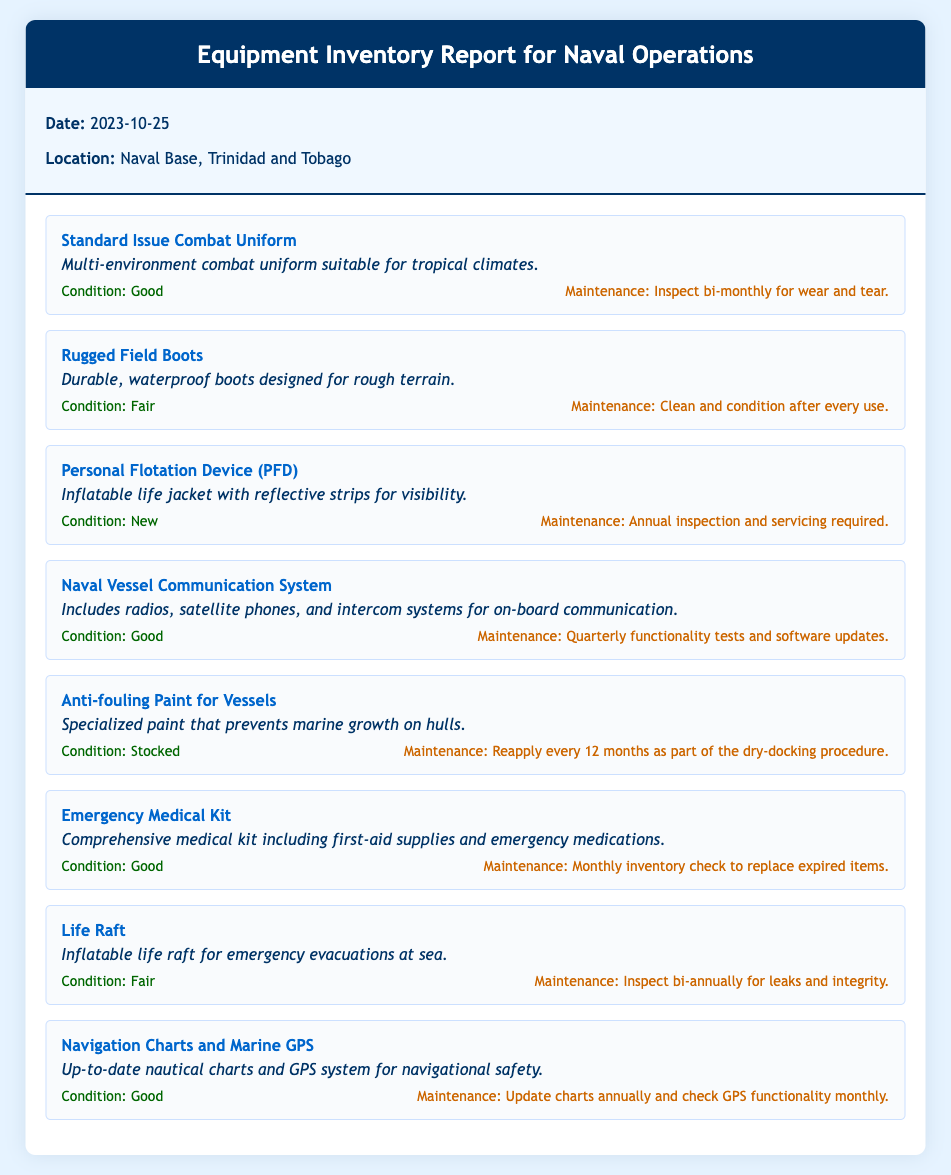What is the date of the report? The report date is specified in the document under the 'Date' heading.
Answer: 2023-10-25 What item is described as suitable for tropical climates? The item suitability is indicated in the description, highlighting its appropriateness for the environment.
Answer: Standard Issue Combat Uniform What is the condition of the Personal Flotation Device? The condition is explicitly mentioned in the details of the item.
Answer: New How often should the Emergency Medical Kit be checked? This maintenance schedule is outlined clearly in the item details section.
Answer: Monthly What type of boots are mentioned in the report? The report describes the features of the boots under their name and description.
Answer: Rugged Field Boots Which item requires a quarterly functionality test? The maintenance information indicates this requirement clearly next to the item's name.
Answer: Naval Vessel Communication System How frequently should the Anti-fouling Paint be reapplied? This maintenance frequency is part of the item's maintenance schedule in the document.
Answer: Every 12 months What is the maintenance recommendation for the Life Raft? The document lists this maintenance task alongside the item details, indicating the inspection frequency.
Answer: Bi-annually What is the purpose of the Navigation Charts and Marine GPS? The item description outlines its intended use for ensuring safety while navigating.
Answer: Navigational safety 